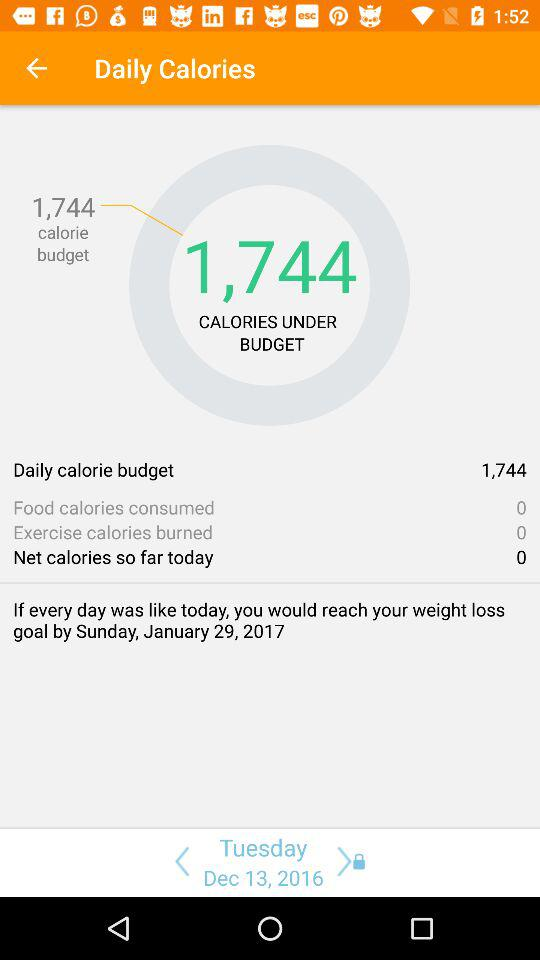What is the amount of calories? The amount of calories is 1,744. 